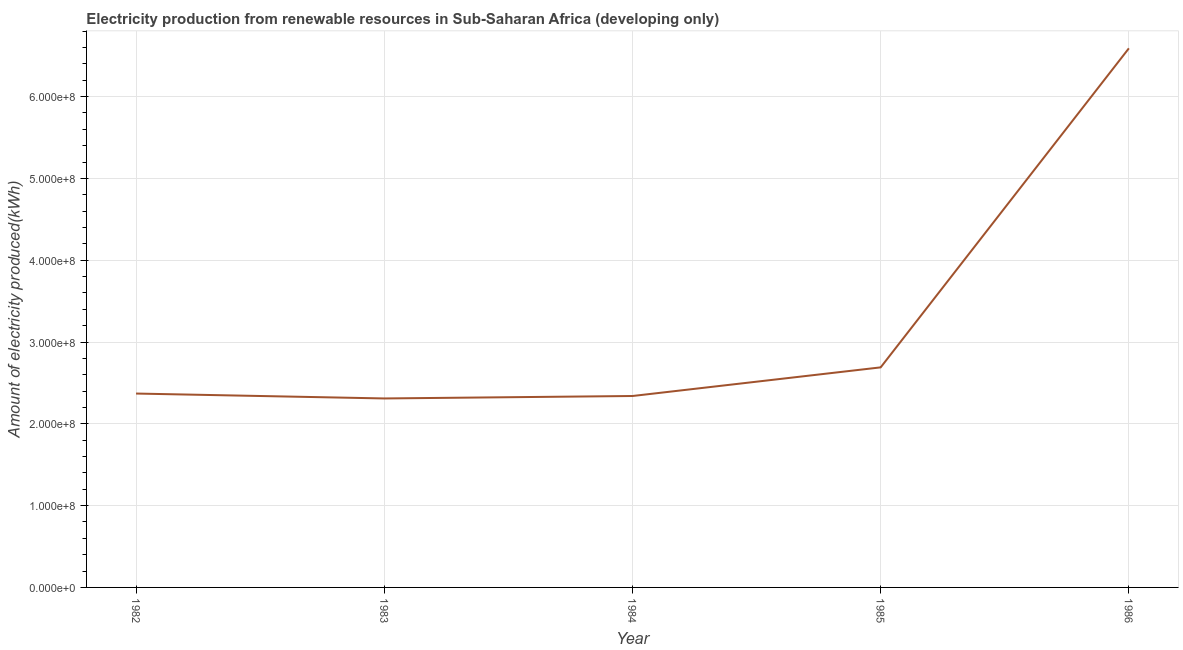What is the amount of electricity produced in 1983?
Ensure brevity in your answer.  2.31e+08. Across all years, what is the maximum amount of electricity produced?
Offer a terse response. 6.59e+08. Across all years, what is the minimum amount of electricity produced?
Your response must be concise. 2.31e+08. In which year was the amount of electricity produced maximum?
Provide a short and direct response. 1986. In which year was the amount of electricity produced minimum?
Ensure brevity in your answer.  1983. What is the sum of the amount of electricity produced?
Offer a very short reply. 1.63e+09. What is the difference between the amount of electricity produced in 1984 and 1985?
Provide a short and direct response. -3.50e+07. What is the average amount of electricity produced per year?
Provide a succinct answer. 3.26e+08. What is the median amount of electricity produced?
Provide a succinct answer. 2.37e+08. What is the ratio of the amount of electricity produced in 1982 to that in 1983?
Your answer should be very brief. 1.03. Is the amount of electricity produced in 1984 less than that in 1986?
Your answer should be very brief. Yes. Is the difference between the amount of electricity produced in 1982 and 1983 greater than the difference between any two years?
Provide a succinct answer. No. What is the difference between the highest and the second highest amount of electricity produced?
Give a very brief answer. 3.90e+08. What is the difference between the highest and the lowest amount of electricity produced?
Ensure brevity in your answer.  4.28e+08. What is the title of the graph?
Offer a terse response. Electricity production from renewable resources in Sub-Saharan Africa (developing only). What is the label or title of the Y-axis?
Make the answer very short. Amount of electricity produced(kWh). What is the Amount of electricity produced(kWh) in 1982?
Your answer should be very brief. 2.37e+08. What is the Amount of electricity produced(kWh) in 1983?
Offer a terse response. 2.31e+08. What is the Amount of electricity produced(kWh) of 1984?
Provide a succinct answer. 2.34e+08. What is the Amount of electricity produced(kWh) of 1985?
Your response must be concise. 2.69e+08. What is the Amount of electricity produced(kWh) of 1986?
Make the answer very short. 6.59e+08. What is the difference between the Amount of electricity produced(kWh) in 1982 and 1984?
Offer a very short reply. 3.00e+06. What is the difference between the Amount of electricity produced(kWh) in 1982 and 1985?
Ensure brevity in your answer.  -3.20e+07. What is the difference between the Amount of electricity produced(kWh) in 1982 and 1986?
Your response must be concise. -4.22e+08. What is the difference between the Amount of electricity produced(kWh) in 1983 and 1984?
Provide a succinct answer. -3.00e+06. What is the difference between the Amount of electricity produced(kWh) in 1983 and 1985?
Give a very brief answer. -3.80e+07. What is the difference between the Amount of electricity produced(kWh) in 1983 and 1986?
Your answer should be very brief. -4.28e+08. What is the difference between the Amount of electricity produced(kWh) in 1984 and 1985?
Keep it short and to the point. -3.50e+07. What is the difference between the Amount of electricity produced(kWh) in 1984 and 1986?
Offer a terse response. -4.25e+08. What is the difference between the Amount of electricity produced(kWh) in 1985 and 1986?
Ensure brevity in your answer.  -3.90e+08. What is the ratio of the Amount of electricity produced(kWh) in 1982 to that in 1983?
Ensure brevity in your answer.  1.03. What is the ratio of the Amount of electricity produced(kWh) in 1982 to that in 1984?
Provide a short and direct response. 1.01. What is the ratio of the Amount of electricity produced(kWh) in 1982 to that in 1985?
Provide a short and direct response. 0.88. What is the ratio of the Amount of electricity produced(kWh) in 1982 to that in 1986?
Your answer should be compact. 0.36. What is the ratio of the Amount of electricity produced(kWh) in 1983 to that in 1985?
Your response must be concise. 0.86. What is the ratio of the Amount of electricity produced(kWh) in 1983 to that in 1986?
Ensure brevity in your answer.  0.35. What is the ratio of the Amount of electricity produced(kWh) in 1984 to that in 1985?
Offer a terse response. 0.87. What is the ratio of the Amount of electricity produced(kWh) in 1984 to that in 1986?
Offer a very short reply. 0.35. What is the ratio of the Amount of electricity produced(kWh) in 1985 to that in 1986?
Keep it short and to the point. 0.41. 